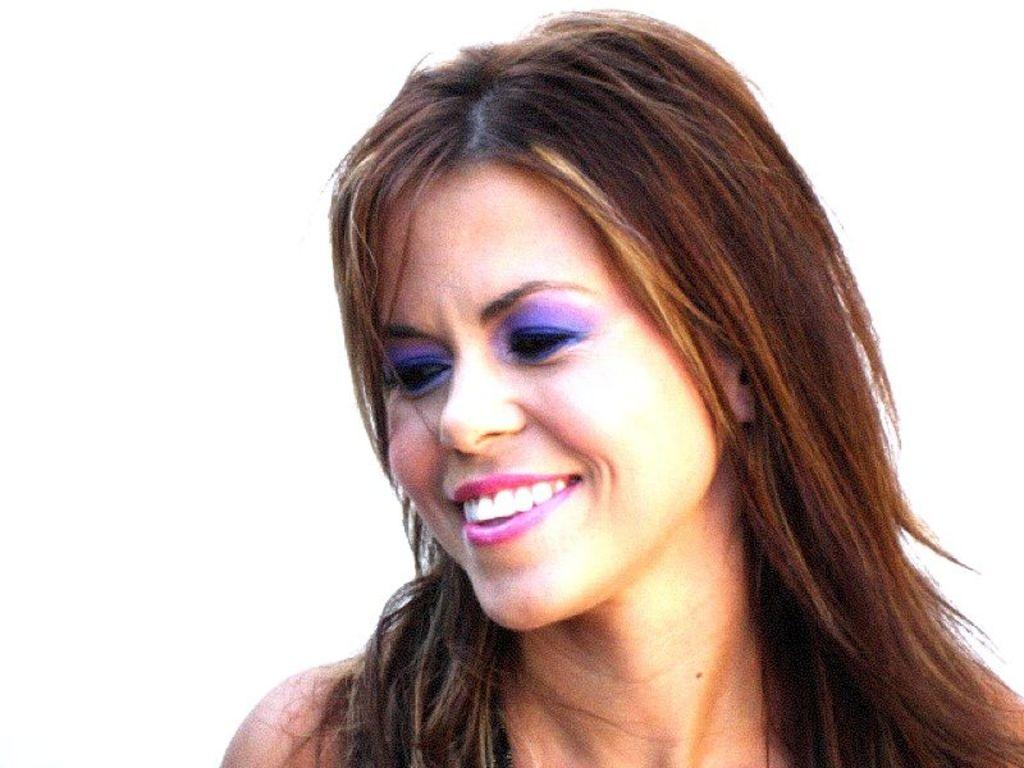Who is the main subject in the image? There is a woman in the image. What expression does the woman have? The woman is smiling. What color is the background of the image? The background of the image is white. Can you tell if the image was taken during the day or night? The image was likely taken during the day, as there is no indication of darkness or artificial lighting. What type of cough medicine is the woman holding in the image? There is no cough medicine present in the image; the woman is not holding anything. How many fingers does the man in the image have? There is no man present in the image, only the woman. 